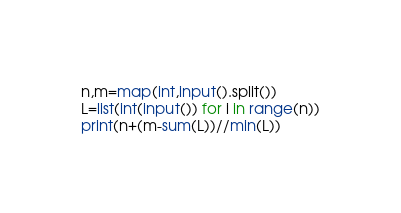<code> <loc_0><loc_0><loc_500><loc_500><_Python_>n,m=map(int,input().split())
L=list(int(input()) for i in range(n))
print(n+(m-sum(L))//min(L))</code> 